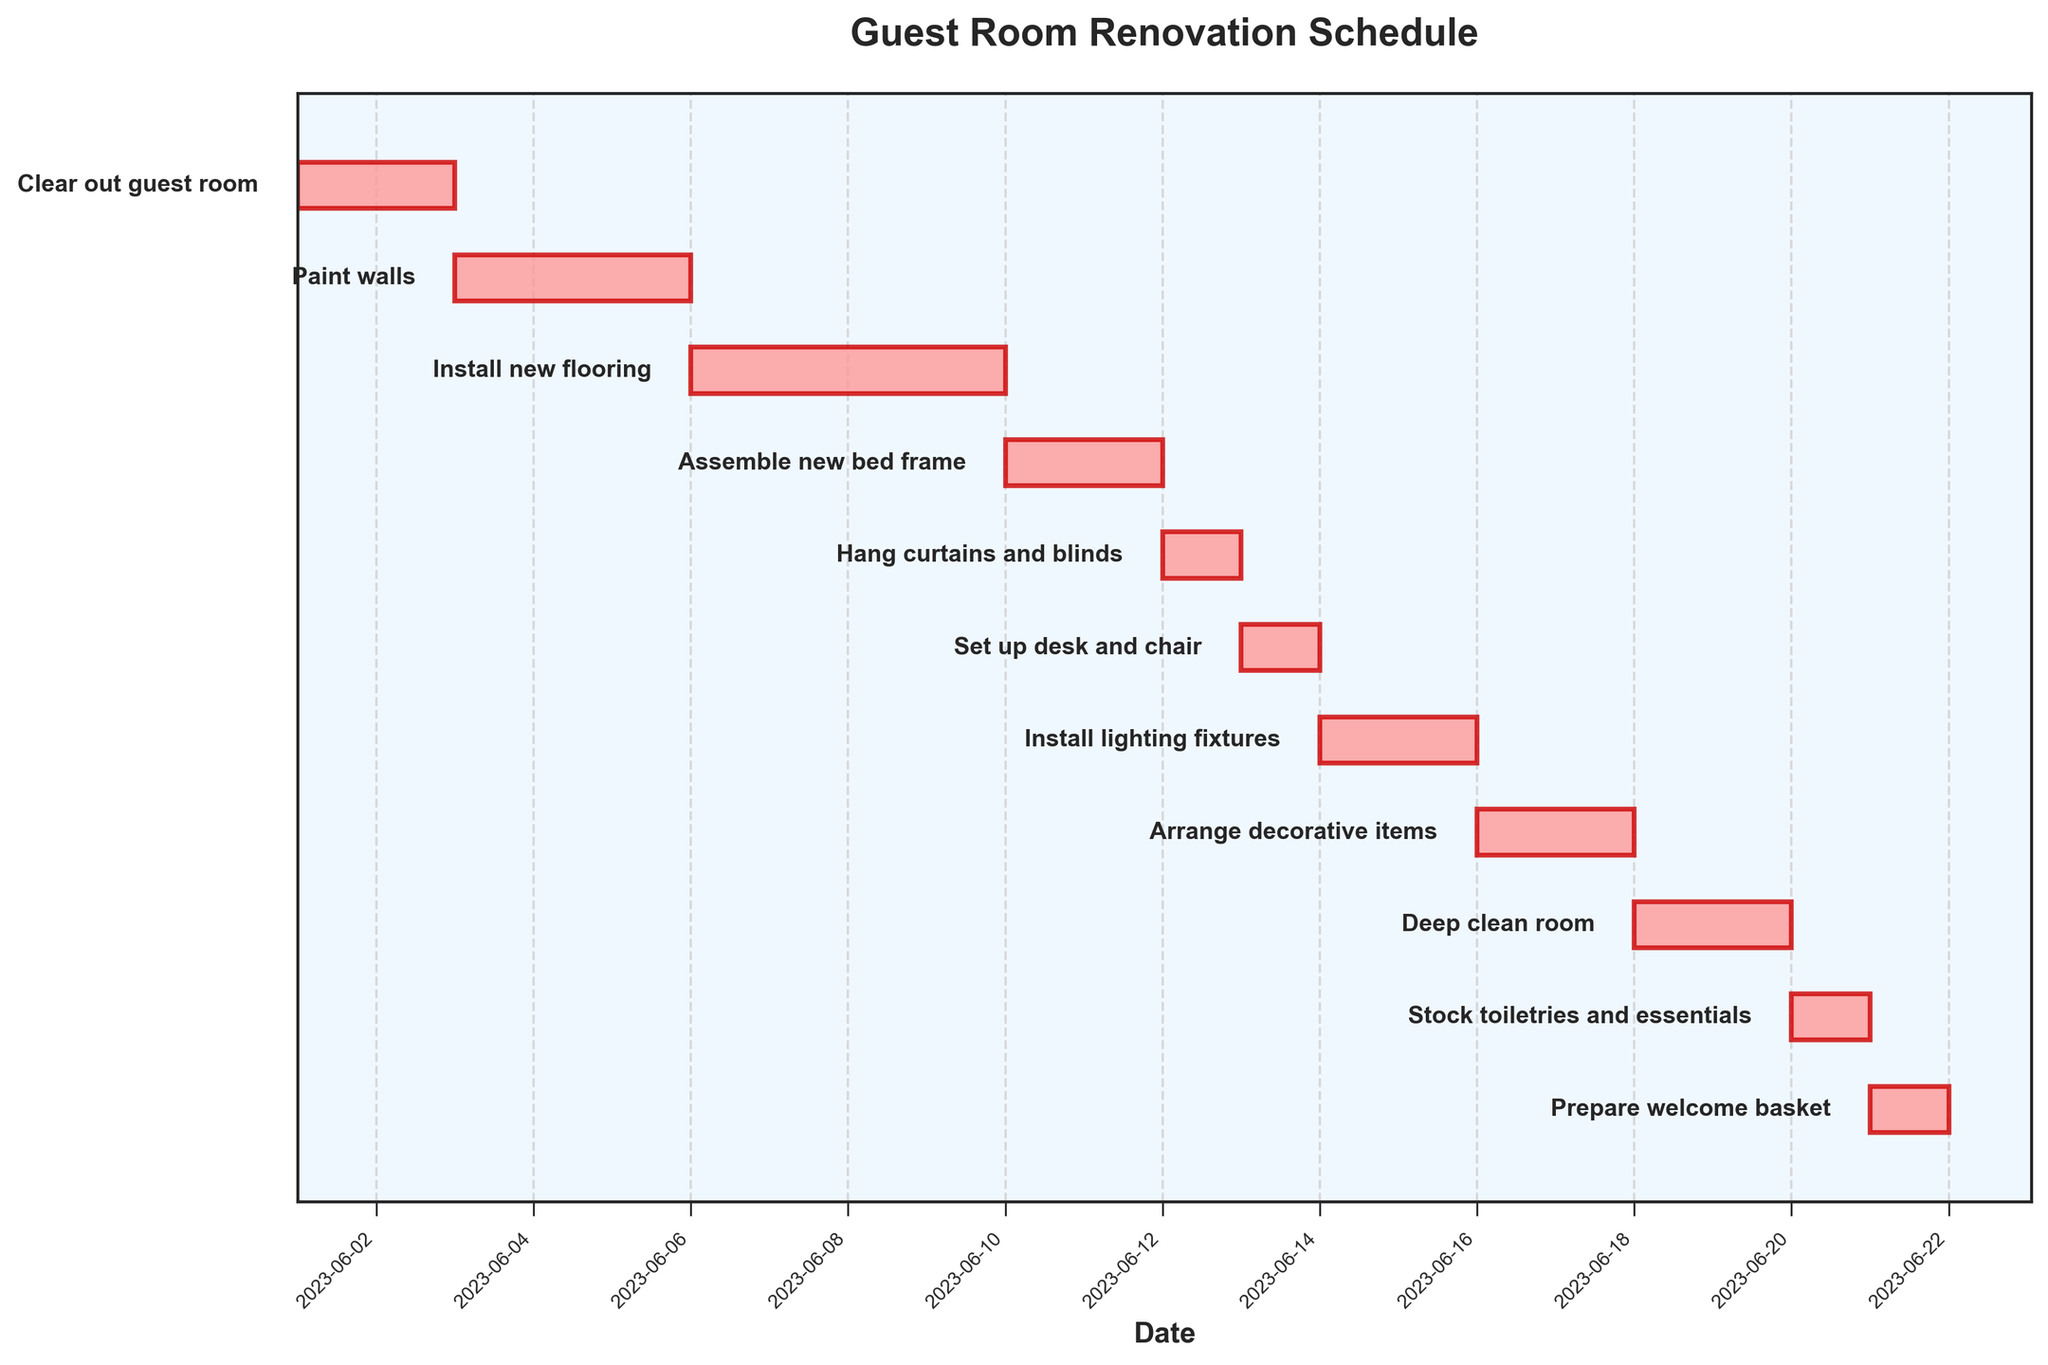What's the earliest task in the schedule? The earliest task is the one with the earliest start date on the chart. Looking at the Gantt Chart, "Clear out guest room" is scheduled to start on 2023-06-01, which is the earliest date.
Answer: Clear out guest room How long does the "Install new flooring" task take? To find the duration of the "Install new flooring" task, look at the length of the bar for the task on the Gantt Chart. It starts on 2023-06-06 and ends on 2023-06-09. Counting the days inclusive, it spans 4 days.
Answer: 4 days Which task ends last in the schedule? The task that ends the latest will have the furthest end date. "Prepare welcome basket" has the latest end date, which is 2023-06-21.
Answer: Prepare welcome basket Are there any tasks that only take one day to complete? To determine this, look for tasks with bars spanning only one day. "Hang curtains and blinds", "Set up desk and chair", "Stock toiletries and essentials", and "Prepare welcome basket" each only span one day.
Answer: Yes What is the total number of days taken to complete the entire renovation? To find the total duration of the renovation, look at the start date of the earliest task and the end date of the latest task. The earliest task starts on 2023-06-01 and the last task ends on 2023-06-21. Therefore, the total duration is from 2023-06-01 to 2023-06-21, which is 21 days.
Answer: 21 days Which tasks are scheduled immediately after "Assemble new bed frame"? To find the tasks immediately after "Assemble new bed frame", check the task ending on 2023-06-11. The next tasks start on 2023-06-12. "Hang curtains and blinds" is scheduled immediately after "Assemble new bed frame".
Answer: Hang curtains and blinds How many tasks are scheduled to take place before the halfway point (June 11)? To find this, count the number of tasks with end dates before June 11. The tasks are: "Clear out guest room", "Paint walls", and "Install new flooring". There are 3 tasks in total.
Answer: 3 tasks Which task has the longest duration? To determine the longest task, look at the longest bar in the Gantt Chart. "Install new flooring" spans 4 days, which is the longest.
Answer: Install new flooring Between "Paint walls" and "Deep clean room", which task starts first? To compare their start dates, look at where each bar begins. "Paint walls" starts on 2023-06-03 and "Deep clean room" starts on 2023-06-18. "Paint walls" starts first.
Answer: Paint walls How many tasks are carried out after "Install lighting fixtures"? To find the number of tasks after "Install lighting fixtures", look for tasks starting after 2023-06-15, which are "Arrange decorative items", "Deep clean room", "Stock toiletries and essentials", and "Prepare welcome basket". There are 4 tasks in total.
Answer: 4 tasks 